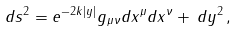<formula> <loc_0><loc_0><loc_500><loc_500>d s ^ { 2 } = e ^ { - 2 k | y | } g _ { \mu \nu } d x ^ { \mu } d x ^ { \nu } + \, d y ^ { 2 } \, ,</formula> 